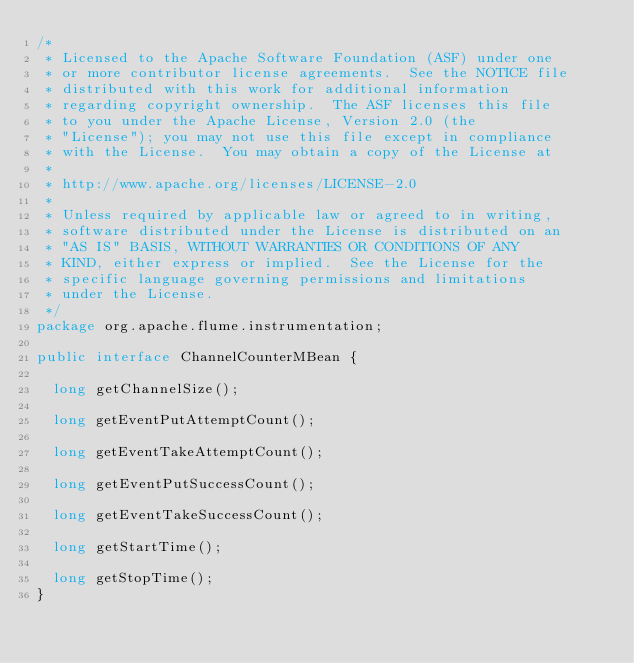Convert code to text. <code><loc_0><loc_0><loc_500><loc_500><_Java_>/*
 * Licensed to the Apache Software Foundation (ASF) under one
 * or more contributor license agreements.  See the NOTICE file
 * distributed with this work for additional information
 * regarding copyright ownership.  The ASF licenses this file
 * to you under the Apache License, Version 2.0 (the
 * "License"); you may not use this file except in compliance
 * with the License.  You may obtain a copy of the License at
 *
 * http://www.apache.org/licenses/LICENSE-2.0
 *
 * Unless required by applicable law or agreed to in writing,
 * software distributed under the License is distributed on an
 * "AS IS" BASIS, WITHOUT WARRANTIES OR CONDITIONS OF ANY
 * KIND, either express or implied.  See the License for the
 * specific language governing permissions and limitations
 * under the License.
 */
package org.apache.flume.instrumentation;

public interface ChannelCounterMBean {

  long getChannelSize();

  long getEventPutAttemptCount();

  long getEventTakeAttemptCount();

  long getEventPutSuccessCount();

  long getEventTakeSuccessCount();

  long getStartTime();

  long getStopTime();
}
</code> 